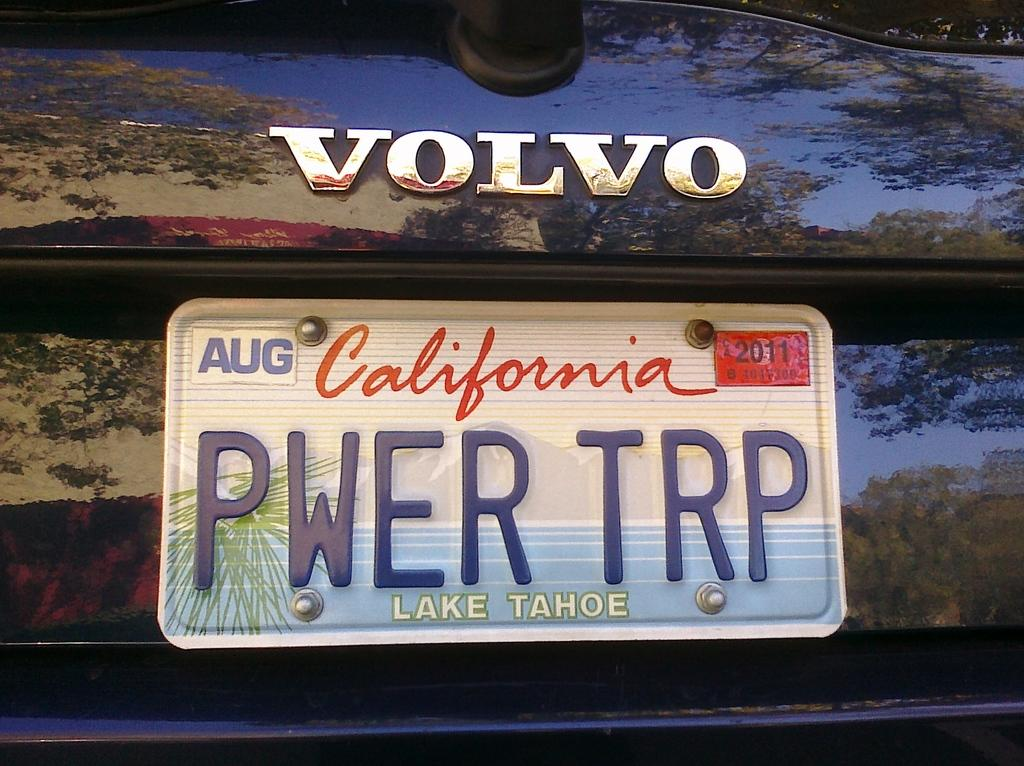<image>
Share a concise interpretation of the image provided. A dark Volvo with a California tag that says PWER TRP on it. 